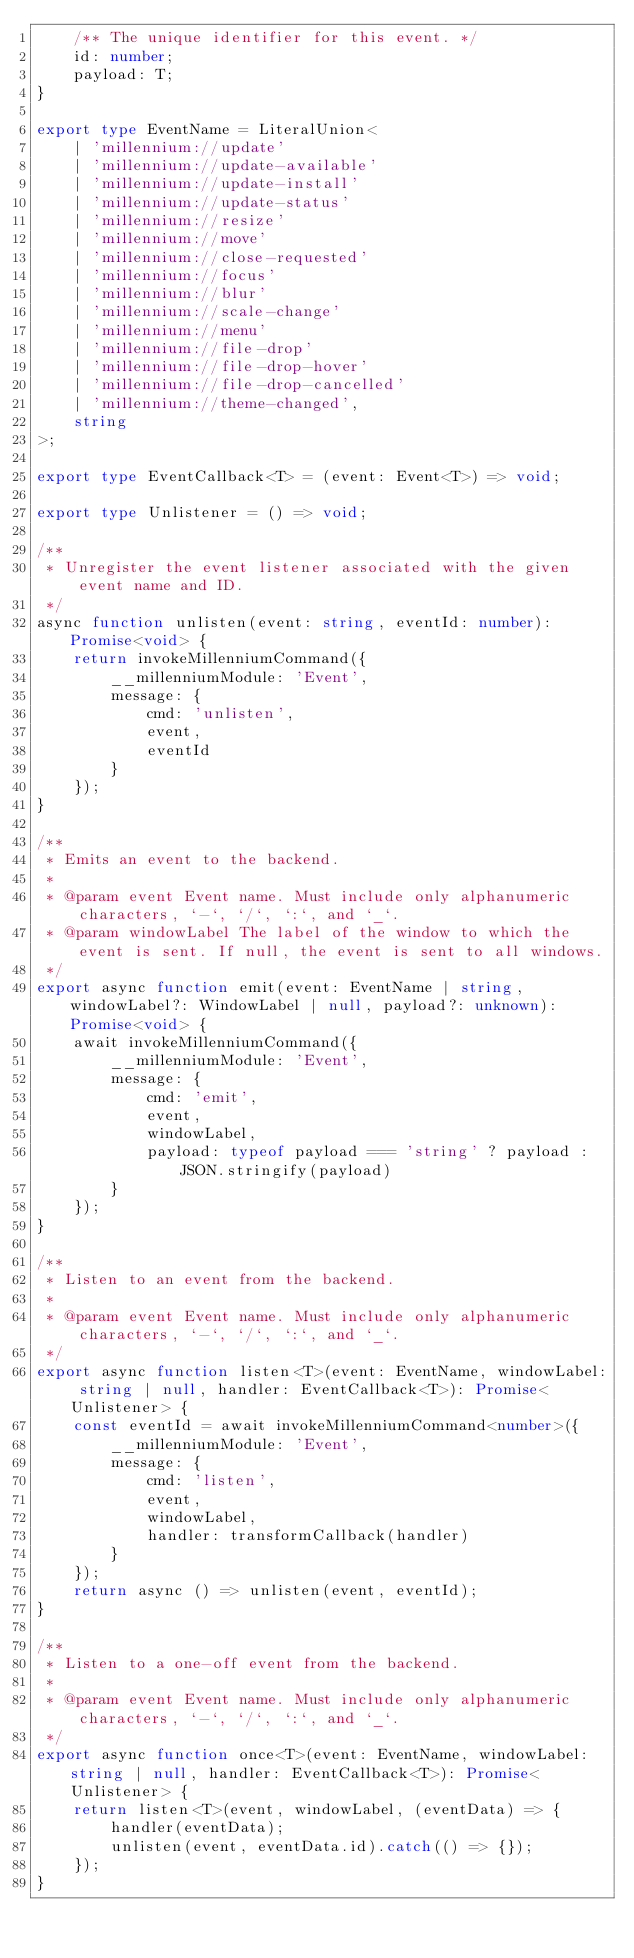<code> <loc_0><loc_0><loc_500><loc_500><_TypeScript_>	/** The unique identifier for this event. */
	id: number;
	payload: T;
}

export type EventName = LiteralUnion<
	| 'millennium://update'
	| 'millennium://update-available'
	| 'millennium://update-install'
	| 'millennium://update-status'
	| 'millennium://resize'
	| 'millennium://move'
	| 'millennium://close-requested'
	| 'millennium://focus'
	| 'millennium://blur'
	| 'millennium://scale-change'
	| 'millennium://menu'
	| 'millennium://file-drop'
	| 'millennium://file-drop-hover'
	| 'millennium://file-drop-cancelled'
	| 'millennium://theme-changed',
	string
>;

export type EventCallback<T> = (event: Event<T>) => void;

export type Unlistener = () => void;

/**
 * Unregister the event listener associated with the given event name and ID.
 */
async function unlisten(event: string, eventId: number): Promise<void> {
	return invokeMillenniumCommand({
		__millenniumModule: 'Event',
		message: {
			cmd: 'unlisten',
			event,
			eventId
		}
	});
}

/**
 * Emits an event to the backend.
 *
 * @param event Event name. Must include only alphanumeric characters, `-`, `/`, `:`, and `_`.
 * @param windowLabel The label of the window to which the event is sent. If null, the event is sent to all windows.
 */
export async function emit(event: EventName | string, windowLabel?: WindowLabel | null, payload?: unknown): Promise<void> {
	await invokeMillenniumCommand({
		__millenniumModule: 'Event',
		message: {
			cmd: 'emit',
			event,
			windowLabel,
			payload: typeof payload === 'string' ? payload : JSON.stringify(payload)
		}
	});
}

/**
 * Listen to an event from the backend.
 *
 * @param event Event name. Must include only alphanumeric characters, `-`, `/`, `:`, and `_`.
 */
export async function listen<T>(event: EventName, windowLabel: string | null, handler: EventCallback<T>): Promise<Unlistener> {
	const eventId = await invokeMillenniumCommand<number>({
		__millenniumModule: 'Event',
		message: {
			cmd: 'listen',
			event,
			windowLabel,
			handler: transformCallback(handler)
		}
	});
	return async () => unlisten(event, eventId);
}

/**
 * Listen to a one-off event from the backend.
 *
 * @param event Event name. Must include only alphanumeric characters, `-`, `/`, `:`, and `_`.
 */
export async function once<T>(event: EventName, windowLabel: string | null, handler: EventCallback<T>): Promise<Unlistener> {
	return listen<T>(event, windowLabel, (eventData) => {
		handler(eventData);
		unlisten(event, eventData.id).catch(() => {});
	});
}
</code> 